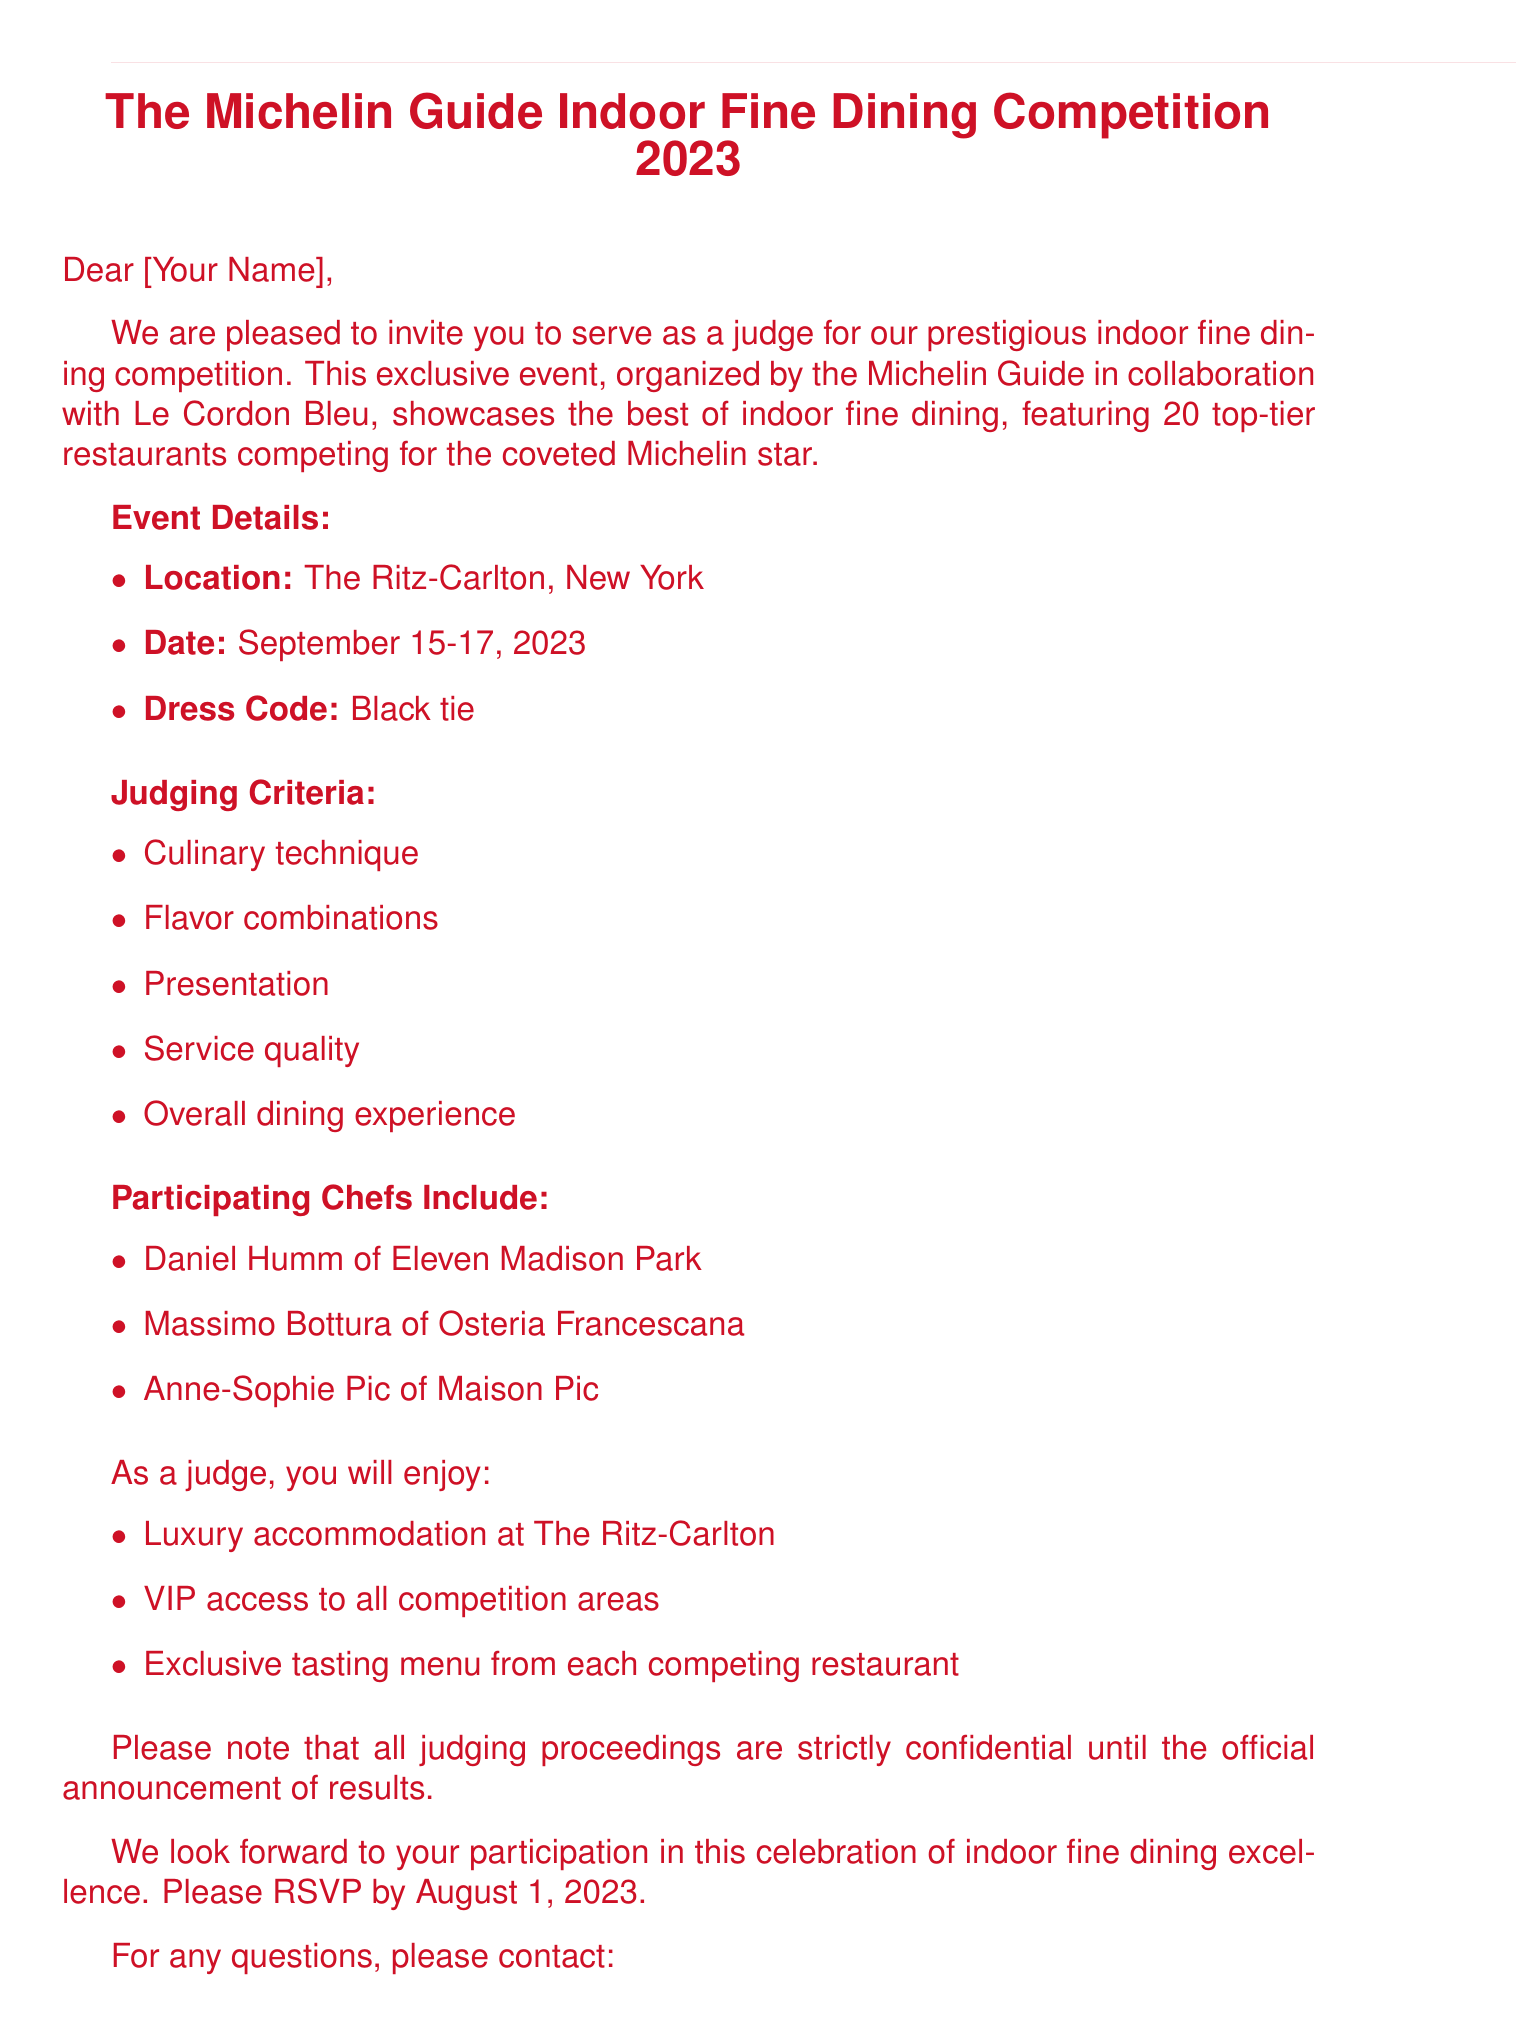What is the name of the competition? The competition is called "The Michelin Guide Indoor Fine Dining Competition 2023".
Answer: The Michelin Guide Indoor Fine Dining Competition 2023 Where is the event taking place? The event is located at "The Ritz-Carlton, New York".
Answer: The Ritz-Carlton, New York What are the dates of the competition? The competition is scheduled for "September 15-17, 2023".
Answer: September 15-17, 2023 How many restaurants are competing for the Michelin star? The document states "20 top-tier restaurants" are competing.
Answer: 20 top-tier restaurants Who is the contact person for the event? The contact person is "Emily Thompson, Event Coordinator".
Answer: Emily Thompson, Event Coordinator What dress code is required for the event? The required dress code is "Black tie".
Answer: Black tie What is the RSVP deadline? The document states that the RSVP deadline is "August 1, 2023".
Answer: August 1, 2023 What is one of the judging criteria? One of the judging criteria includes "Overall dining experience".
Answer: Overall dining experience What is one of the perks for the judges? Judges will receive "Luxury accommodation at The Ritz-Carlton".
Answer: Luxury accommodation at The Ritz-Carlton 